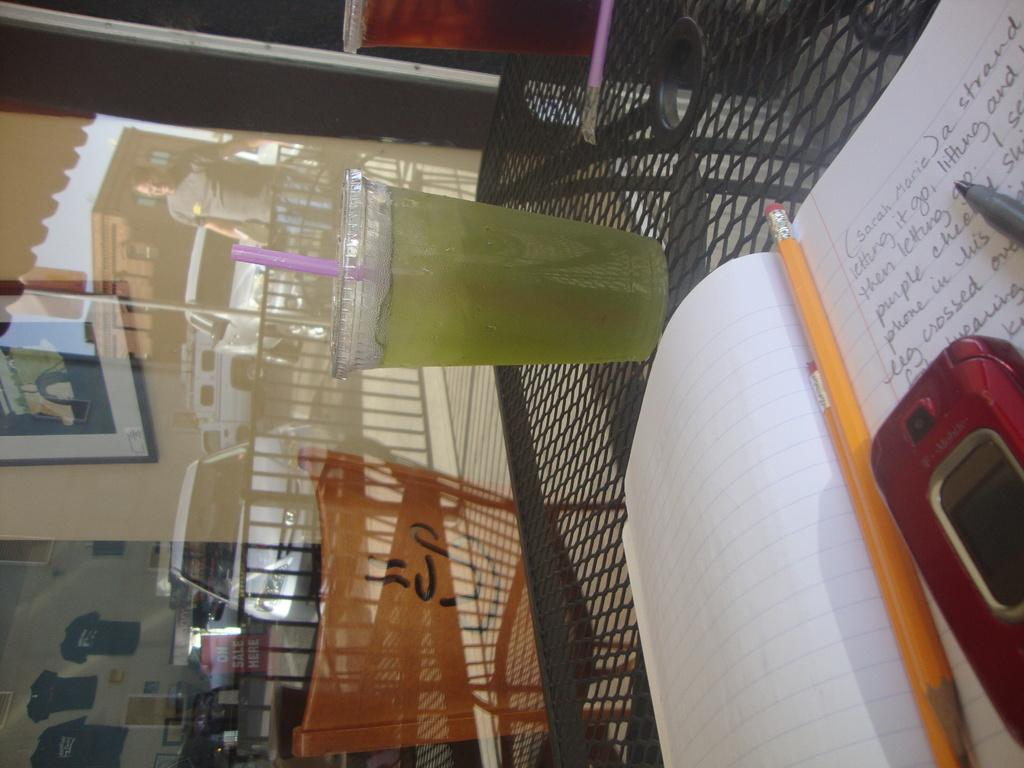<image>
Offer a succinct explanation of the picture presented. A diary that starts with sarah marie and a glass of iced green tea 